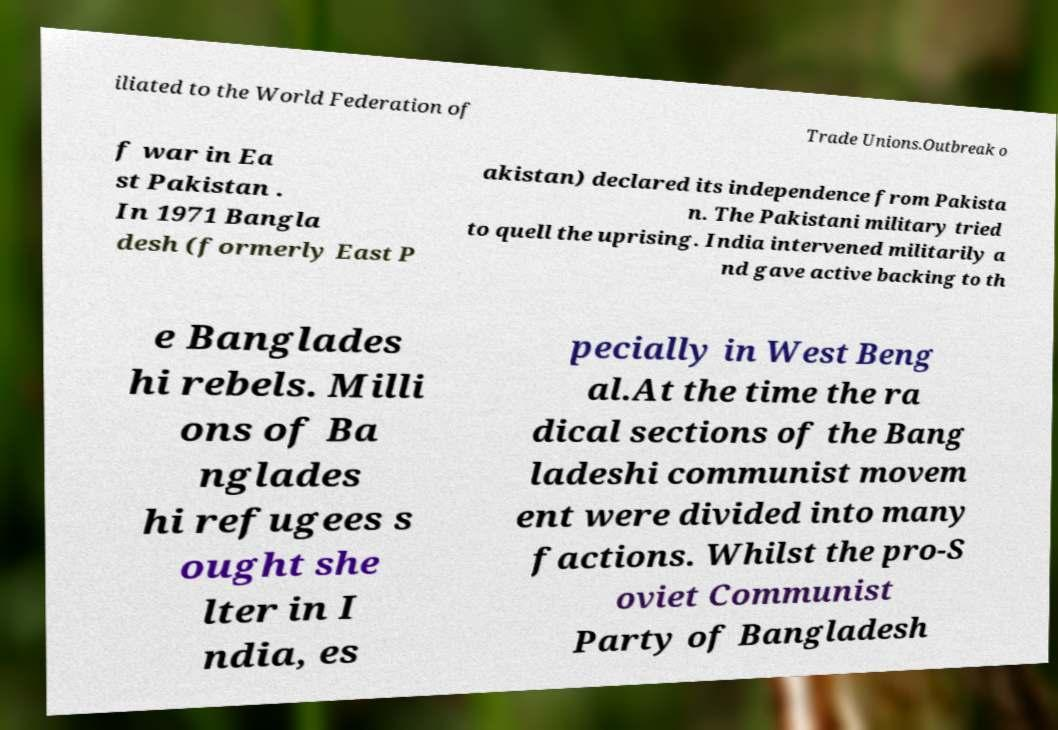For documentation purposes, I need the text within this image transcribed. Could you provide that? iliated to the World Federation of Trade Unions.Outbreak o f war in Ea st Pakistan . In 1971 Bangla desh (formerly East P akistan) declared its independence from Pakista n. The Pakistani military tried to quell the uprising. India intervened militarily a nd gave active backing to th e Banglades hi rebels. Milli ons of Ba nglades hi refugees s ought she lter in I ndia, es pecially in West Beng al.At the time the ra dical sections of the Bang ladeshi communist movem ent were divided into many factions. Whilst the pro-S oviet Communist Party of Bangladesh 